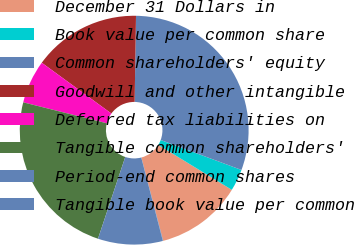<chart> <loc_0><loc_0><loc_500><loc_500><pie_chart><fcel>December 31 Dollars in<fcel>Book value per common share<fcel>Common shareholders' equity<fcel>Goodwill and other intangible<fcel>Deferred tax liabilities on<fcel>Tangible common shareholders'<fcel>Period-end common shares<fcel>Tangible book value per common<nl><fcel>12.19%<fcel>3.08%<fcel>30.4%<fcel>15.22%<fcel>6.12%<fcel>23.79%<fcel>9.15%<fcel>0.05%<nl></chart> 